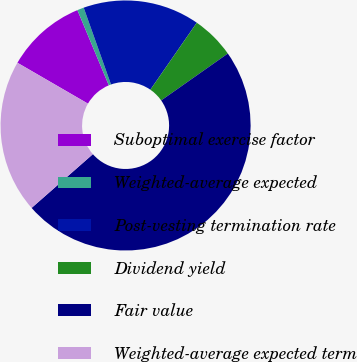Convert chart. <chart><loc_0><loc_0><loc_500><loc_500><pie_chart><fcel>Suboptimal exercise factor<fcel>Weighted-average expected<fcel>Post-vesting termination rate<fcel>Dividend yield<fcel>Fair value<fcel>Weighted-average expected term<nl><fcel>10.34%<fcel>0.86%<fcel>15.08%<fcel>5.6%<fcel>48.29%<fcel>19.82%<nl></chart> 